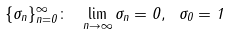<formula> <loc_0><loc_0><loc_500><loc_500>\{ \sigma _ { n } \} _ { n = 0 } ^ { \infty } \colon \ \lim _ { n \rightarrow \infty } \sigma _ { n } = 0 , \ \sigma _ { 0 } = 1</formula> 